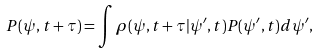<formula> <loc_0><loc_0><loc_500><loc_500>P ( \psi , t + \tau ) = \int \rho ( \psi , t + \tau | \psi ^ { \prime } , t ) P ( \psi ^ { \prime } , t ) d \psi ^ { \prime } ,</formula> 